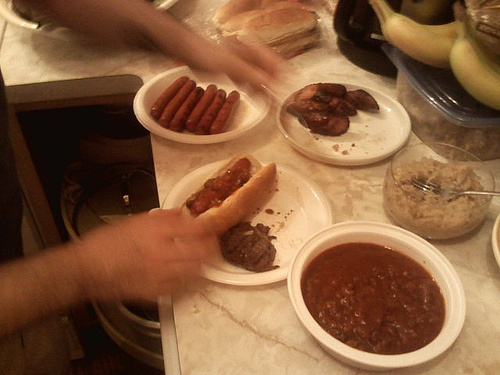Describe the objects in this image and their specific colors. I can see people in tan, brown, maroon, and black tones, bowl in tan and maroon tones, bowl in tan, gray, and brown tones, banana in tan and olive tones, and hot dog in tan, brown, and maroon tones in this image. 